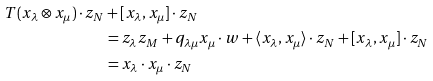Convert formula to latex. <formula><loc_0><loc_0><loc_500><loc_500>T ( x _ { \lambda } \otimes x _ { \mu } ) \cdot z _ { N } & + [ x _ { \lambda } , x _ { \mu } ] \cdot z _ { N } \\ & = z _ { \lambda } z _ { M } + q _ { \lambda \mu } x _ { \mu } \cdot w + \langle x _ { \lambda } , x _ { \mu } \rangle \cdot z _ { N } + [ x _ { \lambda } , x _ { \mu } ] \cdot z _ { N } \\ & = x _ { \lambda } \cdot x _ { \mu } \cdot z _ { N }</formula> 